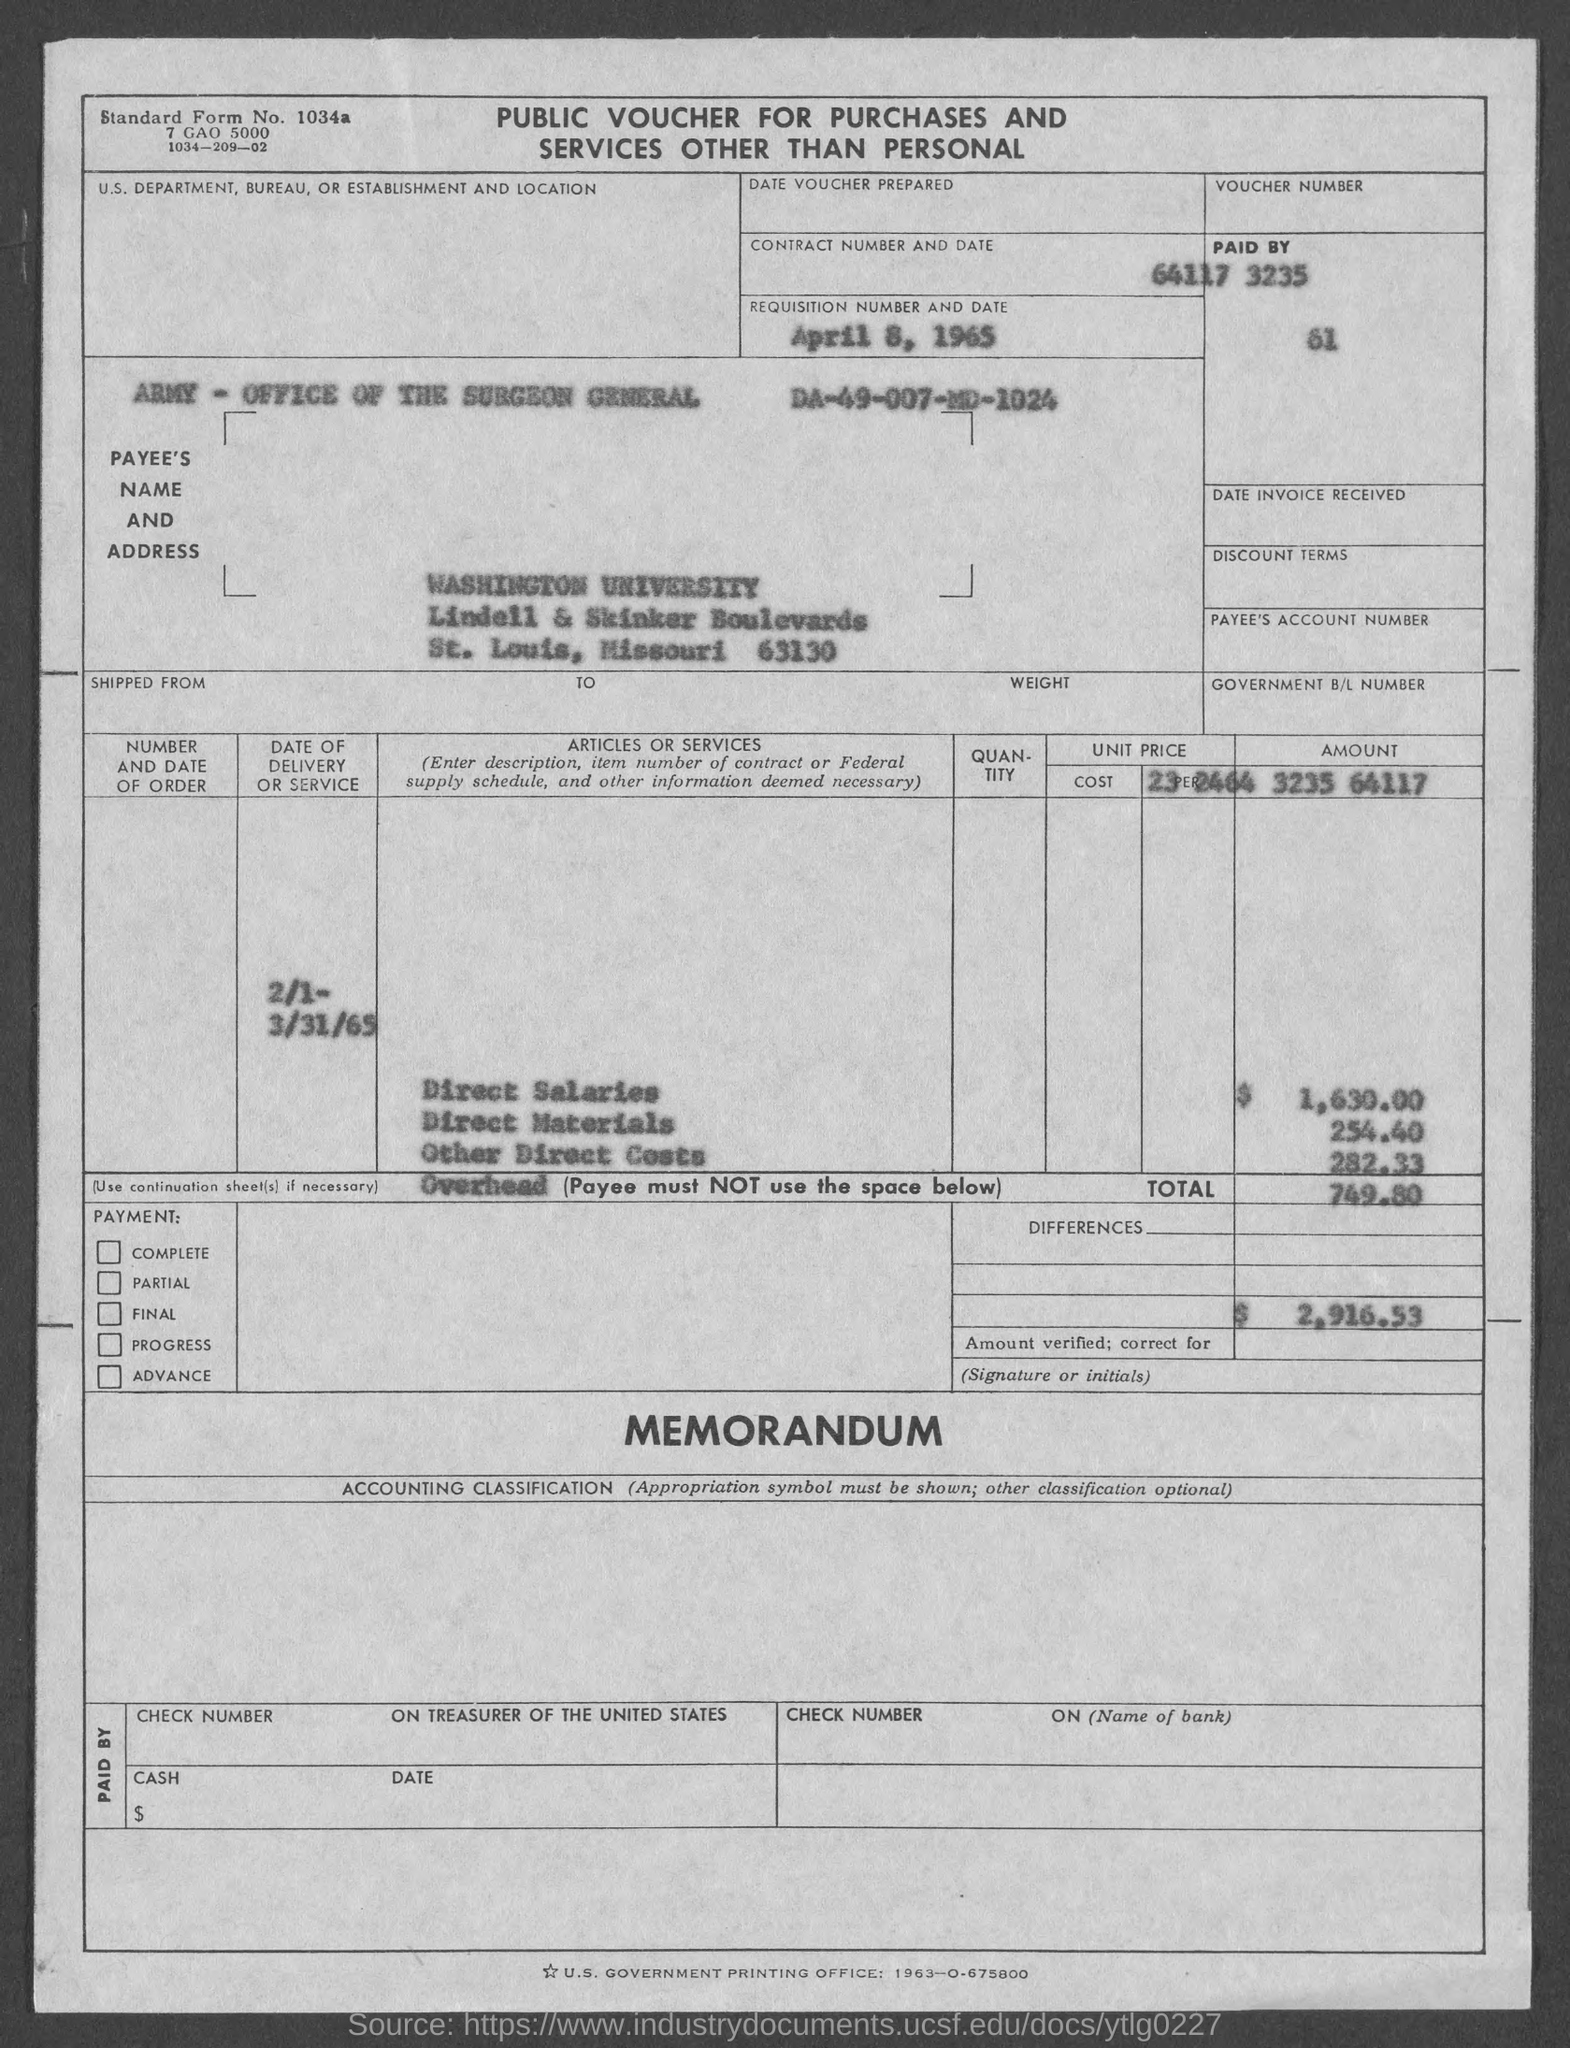What is the name of the voucher ?
Give a very brief answer. Public Voucher for Purchases and Services other than Personal. What is the date of requisition ?
Make the answer very short. April 8, 1965. What is the standard form no.?
Make the answer very short. 1034a. 